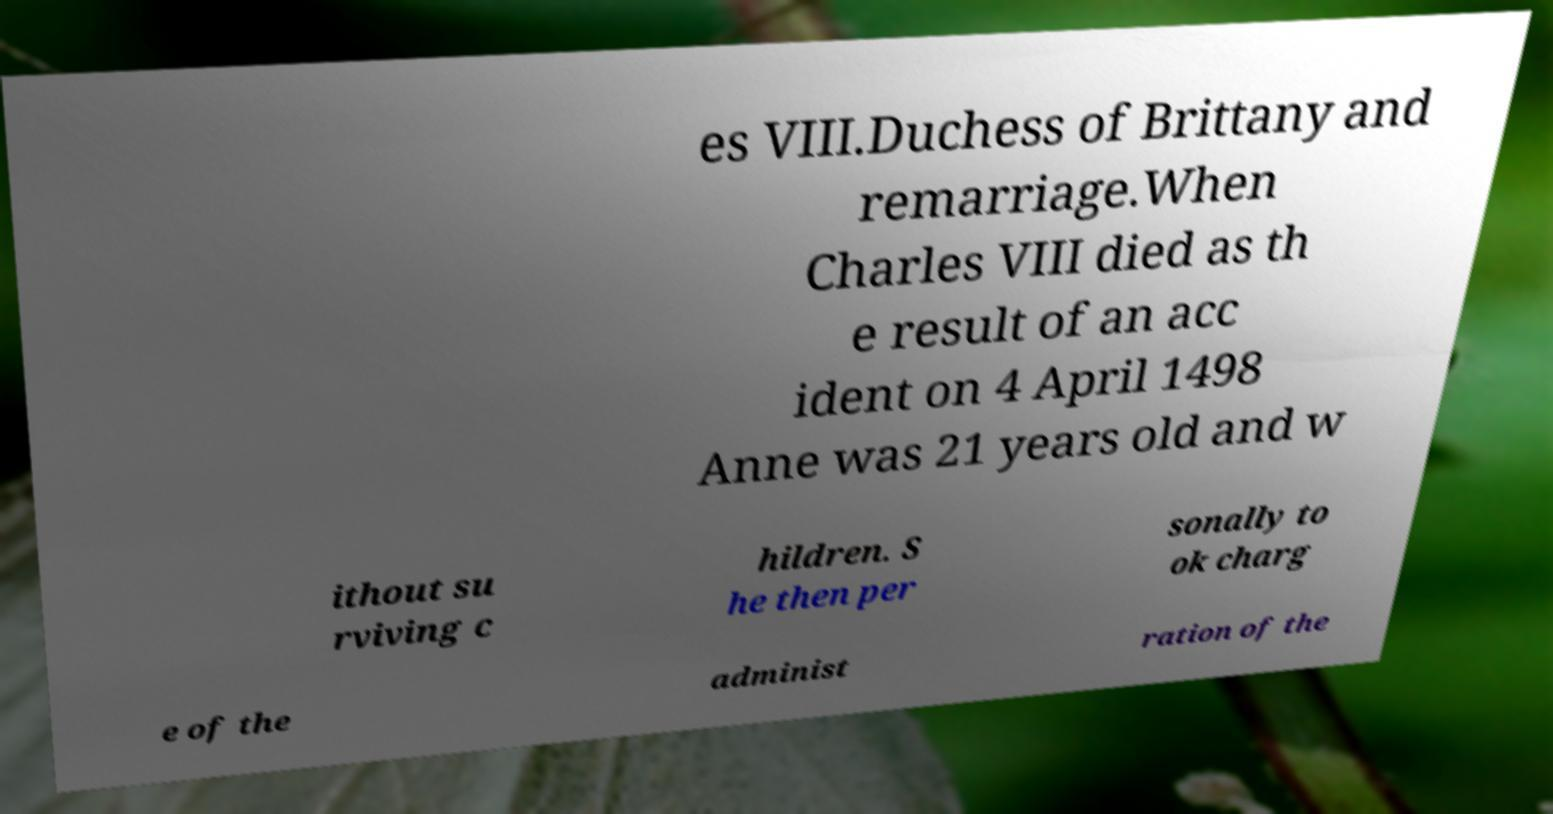Could you extract and type out the text from this image? es VIII.Duchess of Brittany and remarriage.When Charles VIII died as th e result of an acc ident on 4 April 1498 Anne was 21 years old and w ithout su rviving c hildren. S he then per sonally to ok charg e of the administ ration of the 